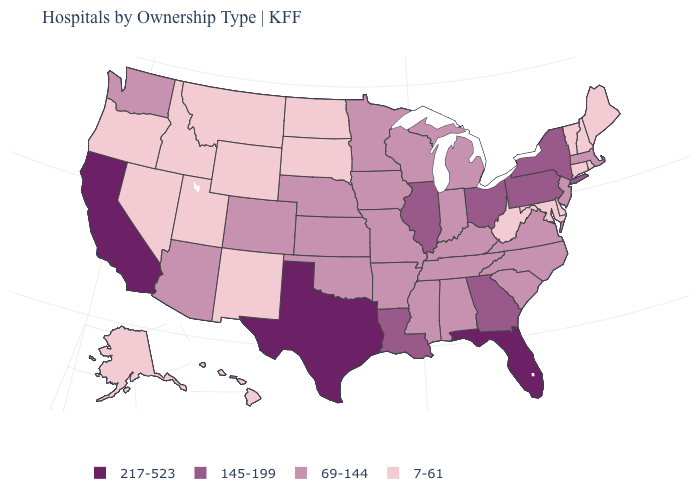Does Oklahoma have a higher value than Idaho?
Give a very brief answer. Yes. What is the value of Nebraska?
Quick response, please. 69-144. Name the states that have a value in the range 7-61?
Write a very short answer. Alaska, Connecticut, Delaware, Hawaii, Idaho, Maine, Maryland, Montana, Nevada, New Hampshire, New Mexico, North Dakota, Oregon, Rhode Island, South Dakota, Utah, Vermont, West Virginia, Wyoming. Does the map have missing data?
Be succinct. No. Which states have the highest value in the USA?
Short answer required. California, Florida, Texas. Which states hav the highest value in the Northeast?
Give a very brief answer. New York, Pennsylvania. What is the value of Wisconsin?
Keep it brief. 69-144. What is the lowest value in states that border Tennessee?
Concise answer only. 69-144. Does Massachusetts have a lower value than Louisiana?
Concise answer only. Yes. Name the states that have a value in the range 145-199?
Concise answer only. Georgia, Illinois, Louisiana, New York, Ohio, Pennsylvania. Does Louisiana have the lowest value in the USA?
Quick response, please. No. Does the map have missing data?
Write a very short answer. No. Name the states that have a value in the range 69-144?
Answer briefly. Alabama, Arizona, Arkansas, Colorado, Indiana, Iowa, Kansas, Kentucky, Massachusetts, Michigan, Minnesota, Mississippi, Missouri, Nebraska, New Jersey, North Carolina, Oklahoma, South Carolina, Tennessee, Virginia, Washington, Wisconsin. What is the value of Kansas?
Concise answer only. 69-144. What is the lowest value in the MidWest?
Give a very brief answer. 7-61. 